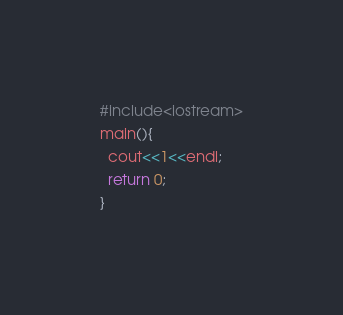Convert code to text. <code><loc_0><loc_0><loc_500><loc_500><_C++_>#include<iostream>
main(){
  cout<<1<<endl;
  return 0;
}</code> 